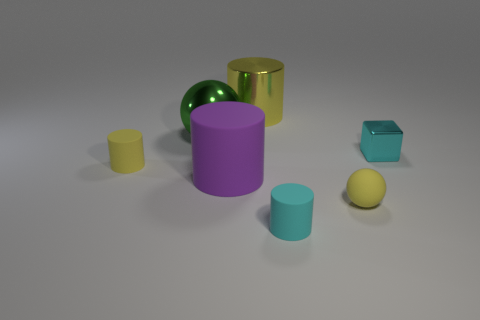Add 2 purple rubber objects. How many objects exist? 9 Subtract all cubes. How many objects are left? 6 Add 5 big objects. How many big objects are left? 8 Add 4 large rubber cylinders. How many large rubber cylinders exist? 5 Subtract 1 purple cylinders. How many objects are left? 6 Subtract all big rubber cylinders. Subtract all small purple matte balls. How many objects are left? 6 